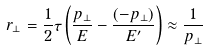Convert formula to latex. <formula><loc_0><loc_0><loc_500><loc_500>r _ { \perp } = \frac { 1 } { 2 } \tau \left ( \frac { p _ { \perp } } { E } - \frac { ( - p _ { \perp } ) } { E ^ { \prime } } \right ) \approx \frac { 1 } { p _ { \perp } }</formula> 